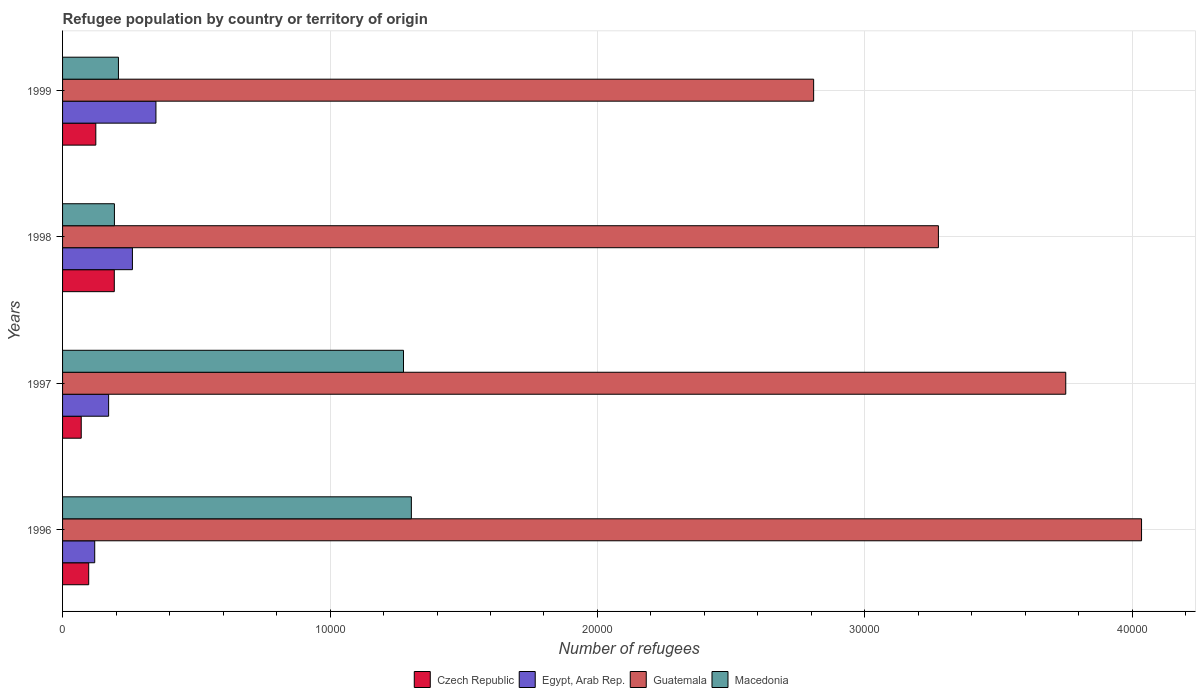How many groups of bars are there?
Make the answer very short. 4. Are the number of bars on each tick of the Y-axis equal?
Offer a terse response. Yes. How many bars are there on the 2nd tick from the bottom?
Offer a terse response. 4. What is the label of the 4th group of bars from the top?
Offer a very short reply. 1996. In how many cases, is the number of bars for a given year not equal to the number of legend labels?
Provide a short and direct response. 0. What is the number of refugees in Macedonia in 1996?
Your answer should be compact. 1.30e+04. Across all years, what is the maximum number of refugees in Czech Republic?
Give a very brief answer. 1934. Across all years, what is the minimum number of refugees in Egypt, Arab Rep.?
Provide a short and direct response. 1202. In which year was the number of refugees in Macedonia maximum?
Make the answer very short. 1996. What is the total number of refugees in Czech Republic in the graph?
Offer a very short reply. 4852. What is the difference between the number of refugees in Guatemala in 1997 and that in 1999?
Give a very brief answer. 9426. What is the difference between the number of refugees in Czech Republic in 1998 and the number of refugees in Guatemala in 1999?
Provide a succinct answer. -2.61e+04. What is the average number of refugees in Czech Republic per year?
Offer a terse response. 1213. In the year 1998, what is the difference between the number of refugees in Czech Republic and number of refugees in Egypt, Arab Rep.?
Offer a terse response. -678. What is the ratio of the number of refugees in Czech Republic in 1996 to that in 1999?
Offer a very short reply. 0.79. Is the difference between the number of refugees in Czech Republic in 1997 and 1998 greater than the difference between the number of refugees in Egypt, Arab Rep. in 1997 and 1998?
Offer a terse response. No. What is the difference between the highest and the second highest number of refugees in Guatemala?
Your answer should be very brief. 2834. What is the difference between the highest and the lowest number of refugees in Guatemala?
Give a very brief answer. 1.23e+04. What does the 3rd bar from the top in 1999 represents?
Give a very brief answer. Egypt, Arab Rep. What does the 4th bar from the bottom in 1998 represents?
Offer a terse response. Macedonia. Is it the case that in every year, the sum of the number of refugees in Guatemala and number of refugees in Macedonia is greater than the number of refugees in Egypt, Arab Rep.?
Your answer should be very brief. Yes. How many bars are there?
Offer a very short reply. 16. How many years are there in the graph?
Give a very brief answer. 4. What is the difference between two consecutive major ticks on the X-axis?
Your answer should be very brief. 10000. Does the graph contain any zero values?
Your answer should be compact. No. Does the graph contain grids?
Provide a succinct answer. Yes. Where does the legend appear in the graph?
Provide a short and direct response. Bottom center. How many legend labels are there?
Give a very brief answer. 4. How are the legend labels stacked?
Offer a very short reply. Horizontal. What is the title of the graph?
Your response must be concise. Refugee population by country or territory of origin. What is the label or title of the X-axis?
Provide a succinct answer. Number of refugees. What is the Number of refugees of Czech Republic in 1996?
Make the answer very short. 977. What is the Number of refugees in Egypt, Arab Rep. in 1996?
Your response must be concise. 1202. What is the Number of refugees of Guatemala in 1996?
Offer a very short reply. 4.03e+04. What is the Number of refugees in Macedonia in 1996?
Provide a succinct answer. 1.30e+04. What is the Number of refugees in Czech Republic in 1997?
Provide a short and direct response. 698. What is the Number of refugees of Egypt, Arab Rep. in 1997?
Give a very brief answer. 1722. What is the Number of refugees of Guatemala in 1997?
Offer a very short reply. 3.75e+04. What is the Number of refugees of Macedonia in 1997?
Give a very brief answer. 1.27e+04. What is the Number of refugees of Czech Republic in 1998?
Your answer should be very brief. 1934. What is the Number of refugees of Egypt, Arab Rep. in 1998?
Your answer should be compact. 2612. What is the Number of refugees in Guatemala in 1998?
Give a very brief answer. 3.27e+04. What is the Number of refugees of Macedonia in 1998?
Your response must be concise. 1939. What is the Number of refugees in Czech Republic in 1999?
Ensure brevity in your answer.  1243. What is the Number of refugees of Egypt, Arab Rep. in 1999?
Keep it short and to the point. 3491. What is the Number of refugees in Guatemala in 1999?
Ensure brevity in your answer.  2.81e+04. What is the Number of refugees of Macedonia in 1999?
Offer a very short reply. 2089. Across all years, what is the maximum Number of refugees of Czech Republic?
Your answer should be very brief. 1934. Across all years, what is the maximum Number of refugees in Egypt, Arab Rep.?
Keep it short and to the point. 3491. Across all years, what is the maximum Number of refugees in Guatemala?
Your answer should be very brief. 4.03e+04. Across all years, what is the maximum Number of refugees of Macedonia?
Keep it short and to the point. 1.30e+04. Across all years, what is the minimum Number of refugees of Czech Republic?
Your answer should be compact. 698. Across all years, what is the minimum Number of refugees of Egypt, Arab Rep.?
Keep it short and to the point. 1202. Across all years, what is the minimum Number of refugees in Guatemala?
Give a very brief answer. 2.81e+04. Across all years, what is the minimum Number of refugees of Macedonia?
Your answer should be very brief. 1939. What is the total Number of refugees in Czech Republic in the graph?
Ensure brevity in your answer.  4852. What is the total Number of refugees in Egypt, Arab Rep. in the graph?
Ensure brevity in your answer.  9027. What is the total Number of refugees in Guatemala in the graph?
Your answer should be very brief. 1.39e+05. What is the total Number of refugees in Macedonia in the graph?
Your answer should be compact. 2.98e+04. What is the difference between the Number of refugees in Czech Republic in 1996 and that in 1997?
Your answer should be compact. 279. What is the difference between the Number of refugees of Egypt, Arab Rep. in 1996 and that in 1997?
Offer a terse response. -520. What is the difference between the Number of refugees of Guatemala in 1996 and that in 1997?
Keep it short and to the point. 2834. What is the difference between the Number of refugees in Macedonia in 1996 and that in 1997?
Provide a short and direct response. 294. What is the difference between the Number of refugees of Czech Republic in 1996 and that in 1998?
Keep it short and to the point. -957. What is the difference between the Number of refugees of Egypt, Arab Rep. in 1996 and that in 1998?
Provide a short and direct response. -1410. What is the difference between the Number of refugees in Guatemala in 1996 and that in 1998?
Ensure brevity in your answer.  7595. What is the difference between the Number of refugees of Macedonia in 1996 and that in 1998?
Keep it short and to the point. 1.11e+04. What is the difference between the Number of refugees of Czech Republic in 1996 and that in 1999?
Your answer should be very brief. -266. What is the difference between the Number of refugees of Egypt, Arab Rep. in 1996 and that in 1999?
Your answer should be compact. -2289. What is the difference between the Number of refugees in Guatemala in 1996 and that in 1999?
Your response must be concise. 1.23e+04. What is the difference between the Number of refugees of Macedonia in 1996 and that in 1999?
Keep it short and to the point. 1.10e+04. What is the difference between the Number of refugees of Czech Republic in 1997 and that in 1998?
Your answer should be very brief. -1236. What is the difference between the Number of refugees in Egypt, Arab Rep. in 1997 and that in 1998?
Your response must be concise. -890. What is the difference between the Number of refugees of Guatemala in 1997 and that in 1998?
Provide a short and direct response. 4761. What is the difference between the Number of refugees of Macedonia in 1997 and that in 1998?
Provide a short and direct response. 1.08e+04. What is the difference between the Number of refugees of Czech Republic in 1997 and that in 1999?
Offer a very short reply. -545. What is the difference between the Number of refugees in Egypt, Arab Rep. in 1997 and that in 1999?
Ensure brevity in your answer.  -1769. What is the difference between the Number of refugees of Guatemala in 1997 and that in 1999?
Keep it short and to the point. 9426. What is the difference between the Number of refugees of Macedonia in 1997 and that in 1999?
Make the answer very short. 1.07e+04. What is the difference between the Number of refugees in Czech Republic in 1998 and that in 1999?
Your answer should be compact. 691. What is the difference between the Number of refugees of Egypt, Arab Rep. in 1998 and that in 1999?
Your answer should be very brief. -879. What is the difference between the Number of refugees in Guatemala in 1998 and that in 1999?
Offer a terse response. 4665. What is the difference between the Number of refugees of Macedonia in 1998 and that in 1999?
Give a very brief answer. -150. What is the difference between the Number of refugees in Czech Republic in 1996 and the Number of refugees in Egypt, Arab Rep. in 1997?
Provide a succinct answer. -745. What is the difference between the Number of refugees of Czech Republic in 1996 and the Number of refugees of Guatemala in 1997?
Your response must be concise. -3.65e+04. What is the difference between the Number of refugees of Czech Republic in 1996 and the Number of refugees of Macedonia in 1997?
Provide a short and direct response. -1.18e+04. What is the difference between the Number of refugees of Egypt, Arab Rep. in 1996 and the Number of refugees of Guatemala in 1997?
Provide a succinct answer. -3.63e+04. What is the difference between the Number of refugees of Egypt, Arab Rep. in 1996 and the Number of refugees of Macedonia in 1997?
Your response must be concise. -1.15e+04. What is the difference between the Number of refugees in Guatemala in 1996 and the Number of refugees in Macedonia in 1997?
Keep it short and to the point. 2.76e+04. What is the difference between the Number of refugees of Czech Republic in 1996 and the Number of refugees of Egypt, Arab Rep. in 1998?
Your answer should be compact. -1635. What is the difference between the Number of refugees in Czech Republic in 1996 and the Number of refugees in Guatemala in 1998?
Your answer should be very brief. -3.18e+04. What is the difference between the Number of refugees in Czech Republic in 1996 and the Number of refugees in Macedonia in 1998?
Your answer should be very brief. -962. What is the difference between the Number of refugees of Egypt, Arab Rep. in 1996 and the Number of refugees of Guatemala in 1998?
Your answer should be compact. -3.15e+04. What is the difference between the Number of refugees of Egypt, Arab Rep. in 1996 and the Number of refugees of Macedonia in 1998?
Make the answer very short. -737. What is the difference between the Number of refugees of Guatemala in 1996 and the Number of refugees of Macedonia in 1998?
Offer a terse response. 3.84e+04. What is the difference between the Number of refugees of Czech Republic in 1996 and the Number of refugees of Egypt, Arab Rep. in 1999?
Ensure brevity in your answer.  -2514. What is the difference between the Number of refugees of Czech Republic in 1996 and the Number of refugees of Guatemala in 1999?
Offer a very short reply. -2.71e+04. What is the difference between the Number of refugees in Czech Republic in 1996 and the Number of refugees in Macedonia in 1999?
Provide a short and direct response. -1112. What is the difference between the Number of refugees of Egypt, Arab Rep. in 1996 and the Number of refugees of Guatemala in 1999?
Make the answer very short. -2.69e+04. What is the difference between the Number of refugees of Egypt, Arab Rep. in 1996 and the Number of refugees of Macedonia in 1999?
Give a very brief answer. -887. What is the difference between the Number of refugees in Guatemala in 1996 and the Number of refugees in Macedonia in 1999?
Ensure brevity in your answer.  3.83e+04. What is the difference between the Number of refugees in Czech Republic in 1997 and the Number of refugees in Egypt, Arab Rep. in 1998?
Your response must be concise. -1914. What is the difference between the Number of refugees in Czech Republic in 1997 and the Number of refugees in Guatemala in 1998?
Give a very brief answer. -3.20e+04. What is the difference between the Number of refugees in Czech Republic in 1997 and the Number of refugees in Macedonia in 1998?
Ensure brevity in your answer.  -1241. What is the difference between the Number of refugees of Egypt, Arab Rep. in 1997 and the Number of refugees of Guatemala in 1998?
Your answer should be compact. -3.10e+04. What is the difference between the Number of refugees of Egypt, Arab Rep. in 1997 and the Number of refugees of Macedonia in 1998?
Offer a terse response. -217. What is the difference between the Number of refugees of Guatemala in 1997 and the Number of refugees of Macedonia in 1998?
Keep it short and to the point. 3.56e+04. What is the difference between the Number of refugees of Czech Republic in 1997 and the Number of refugees of Egypt, Arab Rep. in 1999?
Ensure brevity in your answer.  -2793. What is the difference between the Number of refugees in Czech Republic in 1997 and the Number of refugees in Guatemala in 1999?
Make the answer very short. -2.74e+04. What is the difference between the Number of refugees of Czech Republic in 1997 and the Number of refugees of Macedonia in 1999?
Provide a short and direct response. -1391. What is the difference between the Number of refugees in Egypt, Arab Rep. in 1997 and the Number of refugees in Guatemala in 1999?
Offer a terse response. -2.64e+04. What is the difference between the Number of refugees in Egypt, Arab Rep. in 1997 and the Number of refugees in Macedonia in 1999?
Offer a very short reply. -367. What is the difference between the Number of refugees of Guatemala in 1997 and the Number of refugees of Macedonia in 1999?
Keep it short and to the point. 3.54e+04. What is the difference between the Number of refugees of Czech Republic in 1998 and the Number of refugees of Egypt, Arab Rep. in 1999?
Your answer should be compact. -1557. What is the difference between the Number of refugees of Czech Republic in 1998 and the Number of refugees of Guatemala in 1999?
Offer a very short reply. -2.61e+04. What is the difference between the Number of refugees in Czech Republic in 1998 and the Number of refugees in Macedonia in 1999?
Ensure brevity in your answer.  -155. What is the difference between the Number of refugees in Egypt, Arab Rep. in 1998 and the Number of refugees in Guatemala in 1999?
Ensure brevity in your answer.  -2.55e+04. What is the difference between the Number of refugees of Egypt, Arab Rep. in 1998 and the Number of refugees of Macedonia in 1999?
Provide a short and direct response. 523. What is the difference between the Number of refugees in Guatemala in 1998 and the Number of refugees in Macedonia in 1999?
Your answer should be compact. 3.07e+04. What is the average Number of refugees in Czech Republic per year?
Offer a very short reply. 1213. What is the average Number of refugees of Egypt, Arab Rep. per year?
Make the answer very short. 2256.75. What is the average Number of refugees of Guatemala per year?
Provide a short and direct response. 3.47e+04. What is the average Number of refugees of Macedonia per year?
Provide a short and direct response. 7454. In the year 1996, what is the difference between the Number of refugees in Czech Republic and Number of refugees in Egypt, Arab Rep.?
Provide a succinct answer. -225. In the year 1996, what is the difference between the Number of refugees in Czech Republic and Number of refugees in Guatemala?
Provide a short and direct response. -3.94e+04. In the year 1996, what is the difference between the Number of refugees in Czech Republic and Number of refugees in Macedonia?
Your answer should be very brief. -1.21e+04. In the year 1996, what is the difference between the Number of refugees of Egypt, Arab Rep. and Number of refugees of Guatemala?
Your answer should be compact. -3.91e+04. In the year 1996, what is the difference between the Number of refugees of Egypt, Arab Rep. and Number of refugees of Macedonia?
Provide a succinct answer. -1.18e+04. In the year 1996, what is the difference between the Number of refugees of Guatemala and Number of refugees of Macedonia?
Provide a short and direct response. 2.73e+04. In the year 1997, what is the difference between the Number of refugees in Czech Republic and Number of refugees in Egypt, Arab Rep.?
Make the answer very short. -1024. In the year 1997, what is the difference between the Number of refugees in Czech Republic and Number of refugees in Guatemala?
Your answer should be very brief. -3.68e+04. In the year 1997, what is the difference between the Number of refugees of Czech Republic and Number of refugees of Macedonia?
Provide a short and direct response. -1.20e+04. In the year 1997, what is the difference between the Number of refugees of Egypt, Arab Rep. and Number of refugees of Guatemala?
Give a very brief answer. -3.58e+04. In the year 1997, what is the difference between the Number of refugees of Egypt, Arab Rep. and Number of refugees of Macedonia?
Keep it short and to the point. -1.10e+04. In the year 1997, what is the difference between the Number of refugees of Guatemala and Number of refugees of Macedonia?
Your answer should be very brief. 2.48e+04. In the year 1998, what is the difference between the Number of refugees in Czech Republic and Number of refugees in Egypt, Arab Rep.?
Your answer should be compact. -678. In the year 1998, what is the difference between the Number of refugees of Czech Republic and Number of refugees of Guatemala?
Ensure brevity in your answer.  -3.08e+04. In the year 1998, what is the difference between the Number of refugees in Egypt, Arab Rep. and Number of refugees in Guatemala?
Make the answer very short. -3.01e+04. In the year 1998, what is the difference between the Number of refugees of Egypt, Arab Rep. and Number of refugees of Macedonia?
Your answer should be compact. 673. In the year 1998, what is the difference between the Number of refugees of Guatemala and Number of refugees of Macedonia?
Your response must be concise. 3.08e+04. In the year 1999, what is the difference between the Number of refugees of Czech Republic and Number of refugees of Egypt, Arab Rep.?
Your answer should be very brief. -2248. In the year 1999, what is the difference between the Number of refugees of Czech Republic and Number of refugees of Guatemala?
Offer a very short reply. -2.68e+04. In the year 1999, what is the difference between the Number of refugees of Czech Republic and Number of refugees of Macedonia?
Provide a succinct answer. -846. In the year 1999, what is the difference between the Number of refugees in Egypt, Arab Rep. and Number of refugees in Guatemala?
Your answer should be compact. -2.46e+04. In the year 1999, what is the difference between the Number of refugees in Egypt, Arab Rep. and Number of refugees in Macedonia?
Your answer should be compact. 1402. In the year 1999, what is the difference between the Number of refugees of Guatemala and Number of refugees of Macedonia?
Ensure brevity in your answer.  2.60e+04. What is the ratio of the Number of refugees in Czech Republic in 1996 to that in 1997?
Give a very brief answer. 1.4. What is the ratio of the Number of refugees in Egypt, Arab Rep. in 1996 to that in 1997?
Offer a terse response. 0.7. What is the ratio of the Number of refugees in Guatemala in 1996 to that in 1997?
Keep it short and to the point. 1.08. What is the ratio of the Number of refugees of Macedonia in 1996 to that in 1997?
Ensure brevity in your answer.  1.02. What is the ratio of the Number of refugees in Czech Republic in 1996 to that in 1998?
Offer a terse response. 0.51. What is the ratio of the Number of refugees of Egypt, Arab Rep. in 1996 to that in 1998?
Offer a very short reply. 0.46. What is the ratio of the Number of refugees of Guatemala in 1996 to that in 1998?
Offer a terse response. 1.23. What is the ratio of the Number of refugees in Macedonia in 1996 to that in 1998?
Give a very brief answer. 6.73. What is the ratio of the Number of refugees in Czech Republic in 1996 to that in 1999?
Ensure brevity in your answer.  0.79. What is the ratio of the Number of refugees in Egypt, Arab Rep. in 1996 to that in 1999?
Offer a terse response. 0.34. What is the ratio of the Number of refugees of Guatemala in 1996 to that in 1999?
Your answer should be compact. 1.44. What is the ratio of the Number of refugees of Macedonia in 1996 to that in 1999?
Provide a succinct answer. 6.24. What is the ratio of the Number of refugees of Czech Republic in 1997 to that in 1998?
Offer a very short reply. 0.36. What is the ratio of the Number of refugees of Egypt, Arab Rep. in 1997 to that in 1998?
Offer a very short reply. 0.66. What is the ratio of the Number of refugees of Guatemala in 1997 to that in 1998?
Make the answer very short. 1.15. What is the ratio of the Number of refugees in Macedonia in 1997 to that in 1998?
Your answer should be compact. 6.57. What is the ratio of the Number of refugees of Czech Republic in 1997 to that in 1999?
Keep it short and to the point. 0.56. What is the ratio of the Number of refugees of Egypt, Arab Rep. in 1997 to that in 1999?
Give a very brief answer. 0.49. What is the ratio of the Number of refugees of Guatemala in 1997 to that in 1999?
Provide a short and direct response. 1.34. What is the ratio of the Number of refugees in Macedonia in 1997 to that in 1999?
Your answer should be compact. 6.1. What is the ratio of the Number of refugees of Czech Republic in 1998 to that in 1999?
Your response must be concise. 1.56. What is the ratio of the Number of refugees of Egypt, Arab Rep. in 1998 to that in 1999?
Give a very brief answer. 0.75. What is the ratio of the Number of refugees of Guatemala in 1998 to that in 1999?
Ensure brevity in your answer.  1.17. What is the ratio of the Number of refugees of Macedonia in 1998 to that in 1999?
Ensure brevity in your answer.  0.93. What is the difference between the highest and the second highest Number of refugees in Czech Republic?
Make the answer very short. 691. What is the difference between the highest and the second highest Number of refugees of Egypt, Arab Rep.?
Make the answer very short. 879. What is the difference between the highest and the second highest Number of refugees in Guatemala?
Offer a very short reply. 2834. What is the difference between the highest and the second highest Number of refugees in Macedonia?
Ensure brevity in your answer.  294. What is the difference between the highest and the lowest Number of refugees of Czech Republic?
Provide a short and direct response. 1236. What is the difference between the highest and the lowest Number of refugees of Egypt, Arab Rep.?
Your response must be concise. 2289. What is the difference between the highest and the lowest Number of refugees in Guatemala?
Provide a succinct answer. 1.23e+04. What is the difference between the highest and the lowest Number of refugees in Macedonia?
Your answer should be compact. 1.11e+04. 